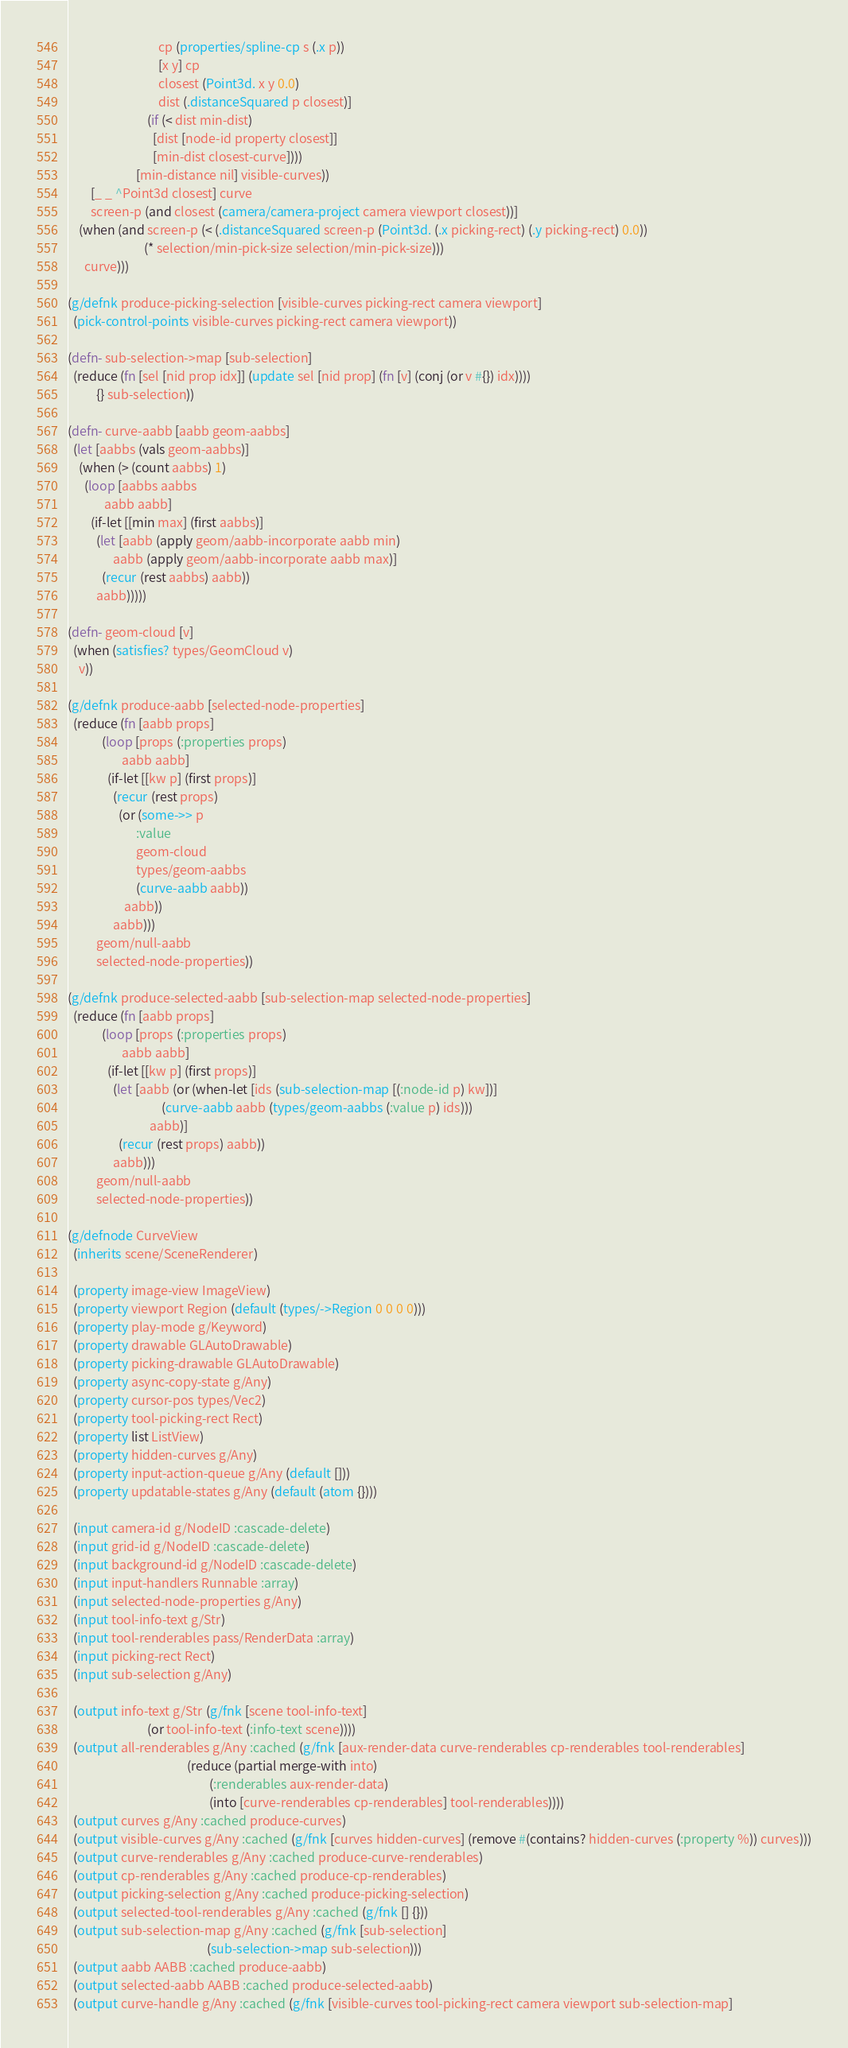Convert code to text. <code><loc_0><loc_0><loc_500><loc_500><_Clojure_>                                cp (properties/spline-cp s (.x p))
                                [x y] cp
                                closest (Point3d. x y 0.0)
                                dist (.distanceSquared p closest)]
                            (if (< dist min-dist)
                              [dist [node-id property closest]]
                              [min-dist closest-curve])))
                        [min-distance nil] visible-curves))
        [_ _ ^Point3d closest] curve
        screen-p (and closest (camera/camera-project camera viewport closest))]
    (when (and screen-p (< (.distanceSquared screen-p (Point3d. (.x picking-rect) (.y picking-rect) 0.0))
                           (* selection/min-pick-size selection/min-pick-size)))
      curve)))

(g/defnk produce-picking-selection [visible-curves picking-rect camera viewport]
  (pick-control-points visible-curves picking-rect camera viewport))

(defn- sub-selection->map [sub-selection]
  (reduce (fn [sel [nid prop idx]] (update sel [nid prop] (fn [v] (conj (or v #{}) idx))))
          {} sub-selection))

(defn- curve-aabb [aabb geom-aabbs]
  (let [aabbs (vals geom-aabbs)]
    (when (> (count aabbs) 1)
      (loop [aabbs aabbs
             aabb aabb]
        (if-let [[min max] (first aabbs)]
          (let [aabb (apply geom/aabb-incorporate aabb min)
                aabb (apply geom/aabb-incorporate aabb max)]
            (recur (rest aabbs) aabb))
          aabb)))))

(defn- geom-cloud [v]
  (when (satisfies? types/GeomCloud v)
    v))

(g/defnk produce-aabb [selected-node-properties]
  (reduce (fn [aabb props]
            (loop [props (:properties props)
                   aabb aabb]
              (if-let [[kw p] (first props)]
                (recur (rest props)
                  (or (some->> p
                        :value
                        geom-cloud
                        types/geom-aabbs
                        (curve-aabb aabb))
                    aabb))
                aabb)))
          geom/null-aabb
          selected-node-properties))

(g/defnk produce-selected-aabb [sub-selection-map selected-node-properties]
  (reduce (fn [aabb props]
            (loop [props (:properties props)
                   aabb aabb]
              (if-let [[kw p] (first props)]
                (let [aabb (or (when-let [ids (sub-selection-map [(:node-id p) kw])]
                                 (curve-aabb aabb (types/geom-aabbs (:value p) ids)))
                             aabb)]
                  (recur (rest props) aabb))
                aabb)))
          geom/null-aabb
          selected-node-properties))

(g/defnode CurveView
  (inherits scene/SceneRenderer)

  (property image-view ImageView)
  (property viewport Region (default (types/->Region 0 0 0 0)))
  (property play-mode g/Keyword)
  (property drawable GLAutoDrawable)
  (property picking-drawable GLAutoDrawable)
  (property async-copy-state g/Any)
  (property cursor-pos types/Vec2)
  (property tool-picking-rect Rect)
  (property list ListView)
  (property hidden-curves g/Any)
  (property input-action-queue g/Any (default []))
  (property updatable-states g/Any (default (atom {})))

  (input camera-id g/NodeID :cascade-delete)
  (input grid-id g/NodeID :cascade-delete)
  (input background-id g/NodeID :cascade-delete)
  (input input-handlers Runnable :array)
  (input selected-node-properties g/Any)
  (input tool-info-text g/Str)
  (input tool-renderables pass/RenderData :array)
  (input picking-rect Rect)
  (input sub-selection g/Any)

  (output info-text g/Str (g/fnk [scene tool-info-text]
                            (or tool-info-text (:info-text scene))))
  (output all-renderables g/Any :cached (g/fnk [aux-render-data curve-renderables cp-renderables tool-renderables]
                                          (reduce (partial merge-with into)
                                                  (:renderables aux-render-data)
                                                  (into [curve-renderables cp-renderables] tool-renderables))))
  (output curves g/Any :cached produce-curves)
  (output visible-curves g/Any :cached (g/fnk [curves hidden-curves] (remove #(contains? hidden-curves (:property %)) curves)))
  (output curve-renderables g/Any :cached produce-curve-renderables)
  (output cp-renderables g/Any :cached produce-cp-renderables)
  (output picking-selection g/Any :cached produce-picking-selection)
  (output selected-tool-renderables g/Any :cached (g/fnk [] {}))
  (output sub-selection-map g/Any :cached (g/fnk [sub-selection]
                                                 (sub-selection->map sub-selection)))
  (output aabb AABB :cached produce-aabb)
  (output selected-aabb AABB :cached produce-selected-aabb)
  (output curve-handle g/Any :cached (g/fnk [visible-curves tool-picking-rect camera viewport sub-selection-map]</code> 